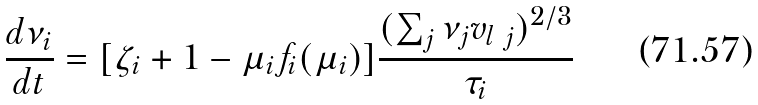Convert formula to latex. <formula><loc_0><loc_0><loc_500><loc_500>\frac { d \nu _ { i } } { d t } = [ \zeta _ { i } + 1 - \mu _ { i } f _ { i } ( \mu _ { i } ) ] \frac { ( \sum _ { j } \nu _ { j } v _ { l \ j } ) ^ { 2 / 3 } } { \tau _ { i } }</formula> 